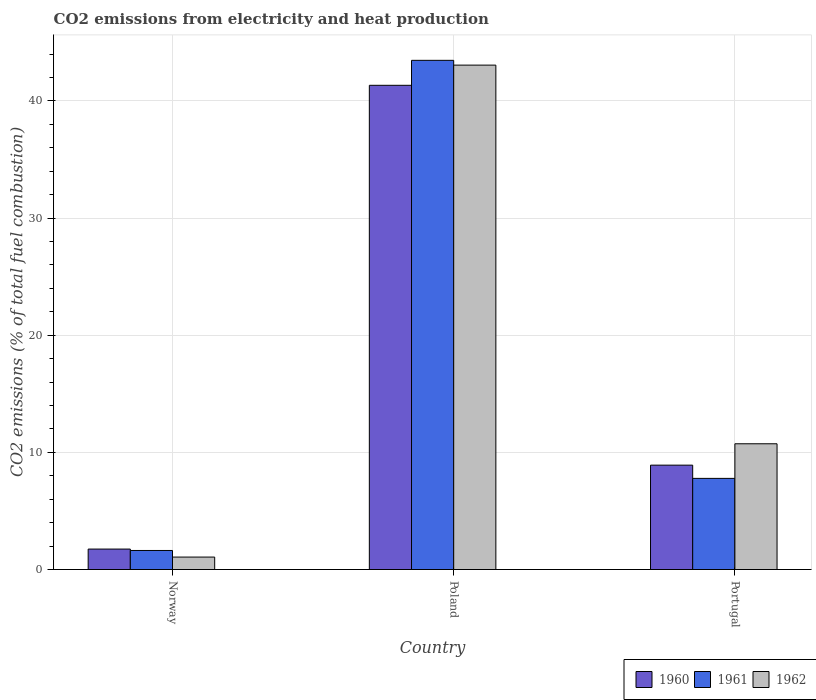How many groups of bars are there?
Your answer should be very brief. 3. How many bars are there on the 3rd tick from the left?
Offer a very short reply. 3. How many bars are there on the 3rd tick from the right?
Ensure brevity in your answer.  3. What is the label of the 3rd group of bars from the left?
Your answer should be compact. Portugal. In how many cases, is the number of bars for a given country not equal to the number of legend labels?
Offer a terse response. 0. What is the amount of CO2 emitted in 1962 in Portugal?
Make the answer very short. 10.73. Across all countries, what is the maximum amount of CO2 emitted in 1962?
Give a very brief answer. 43.06. Across all countries, what is the minimum amount of CO2 emitted in 1962?
Your answer should be very brief. 1.06. What is the total amount of CO2 emitted in 1961 in the graph?
Your answer should be compact. 52.88. What is the difference between the amount of CO2 emitted in 1962 in Norway and that in Portugal?
Give a very brief answer. -9.67. What is the difference between the amount of CO2 emitted in 1961 in Norway and the amount of CO2 emitted in 1962 in Portugal?
Provide a short and direct response. -9.11. What is the average amount of CO2 emitted in 1961 per country?
Your answer should be compact. 17.63. What is the difference between the amount of CO2 emitted of/in 1960 and amount of CO2 emitted of/in 1962 in Portugal?
Provide a succinct answer. -1.82. In how many countries, is the amount of CO2 emitted in 1962 greater than 18 %?
Make the answer very short. 1. What is the ratio of the amount of CO2 emitted in 1961 in Norway to that in Poland?
Keep it short and to the point. 0.04. Is the difference between the amount of CO2 emitted in 1960 in Norway and Portugal greater than the difference between the amount of CO2 emitted in 1962 in Norway and Portugal?
Give a very brief answer. Yes. What is the difference between the highest and the second highest amount of CO2 emitted in 1960?
Offer a very short reply. -32.43. What is the difference between the highest and the lowest amount of CO2 emitted in 1960?
Provide a succinct answer. 39.59. Is it the case that in every country, the sum of the amount of CO2 emitted in 1960 and amount of CO2 emitted in 1962 is greater than the amount of CO2 emitted in 1961?
Offer a terse response. Yes. How many bars are there?
Ensure brevity in your answer.  9. Are all the bars in the graph horizontal?
Your answer should be compact. No. How many countries are there in the graph?
Give a very brief answer. 3. What is the difference between two consecutive major ticks on the Y-axis?
Keep it short and to the point. 10. Are the values on the major ticks of Y-axis written in scientific E-notation?
Keep it short and to the point. No. Does the graph contain grids?
Make the answer very short. Yes. How are the legend labels stacked?
Provide a short and direct response. Horizontal. What is the title of the graph?
Give a very brief answer. CO2 emissions from electricity and heat production. Does "1977" appear as one of the legend labels in the graph?
Your answer should be compact. No. What is the label or title of the X-axis?
Your answer should be very brief. Country. What is the label or title of the Y-axis?
Your answer should be very brief. CO2 emissions (% of total fuel combustion). What is the CO2 emissions (% of total fuel combustion) of 1960 in Norway?
Your response must be concise. 1.75. What is the CO2 emissions (% of total fuel combustion) in 1961 in Norway?
Give a very brief answer. 1.63. What is the CO2 emissions (% of total fuel combustion) of 1962 in Norway?
Offer a very short reply. 1.06. What is the CO2 emissions (% of total fuel combustion) of 1960 in Poland?
Your answer should be very brief. 41.34. What is the CO2 emissions (% of total fuel combustion) in 1961 in Poland?
Your answer should be very brief. 43.47. What is the CO2 emissions (% of total fuel combustion) of 1962 in Poland?
Your response must be concise. 43.06. What is the CO2 emissions (% of total fuel combustion) of 1960 in Portugal?
Ensure brevity in your answer.  8.91. What is the CO2 emissions (% of total fuel combustion) of 1961 in Portugal?
Offer a terse response. 7.78. What is the CO2 emissions (% of total fuel combustion) in 1962 in Portugal?
Offer a very short reply. 10.73. Across all countries, what is the maximum CO2 emissions (% of total fuel combustion) of 1960?
Provide a succinct answer. 41.34. Across all countries, what is the maximum CO2 emissions (% of total fuel combustion) in 1961?
Ensure brevity in your answer.  43.47. Across all countries, what is the maximum CO2 emissions (% of total fuel combustion) of 1962?
Provide a succinct answer. 43.06. Across all countries, what is the minimum CO2 emissions (% of total fuel combustion) of 1960?
Your answer should be compact. 1.75. Across all countries, what is the minimum CO2 emissions (% of total fuel combustion) in 1961?
Offer a terse response. 1.63. Across all countries, what is the minimum CO2 emissions (% of total fuel combustion) of 1962?
Offer a very short reply. 1.06. What is the total CO2 emissions (% of total fuel combustion) in 1960 in the graph?
Offer a very short reply. 51.99. What is the total CO2 emissions (% of total fuel combustion) in 1961 in the graph?
Provide a succinct answer. 52.88. What is the total CO2 emissions (% of total fuel combustion) of 1962 in the graph?
Provide a short and direct response. 54.86. What is the difference between the CO2 emissions (% of total fuel combustion) of 1960 in Norway and that in Poland?
Your response must be concise. -39.59. What is the difference between the CO2 emissions (% of total fuel combustion) in 1961 in Norway and that in Poland?
Keep it short and to the point. -41.84. What is the difference between the CO2 emissions (% of total fuel combustion) of 1962 in Norway and that in Poland?
Provide a succinct answer. -42. What is the difference between the CO2 emissions (% of total fuel combustion) in 1960 in Norway and that in Portugal?
Offer a terse response. -7.16. What is the difference between the CO2 emissions (% of total fuel combustion) of 1961 in Norway and that in Portugal?
Ensure brevity in your answer.  -6.16. What is the difference between the CO2 emissions (% of total fuel combustion) of 1962 in Norway and that in Portugal?
Provide a short and direct response. -9.67. What is the difference between the CO2 emissions (% of total fuel combustion) in 1960 in Poland and that in Portugal?
Make the answer very short. 32.43. What is the difference between the CO2 emissions (% of total fuel combustion) in 1961 in Poland and that in Portugal?
Offer a terse response. 35.69. What is the difference between the CO2 emissions (% of total fuel combustion) of 1962 in Poland and that in Portugal?
Your answer should be very brief. 32.33. What is the difference between the CO2 emissions (% of total fuel combustion) in 1960 in Norway and the CO2 emissions (% of total fuel combustion) in 1961 in Poland?
Offer a terse response. -41.72. What is the difference between the CO2 emissions (% of total fuel combustion) of 1960 in Norway and the CO2 emissions (% of total fuel combustion) of 1962 in Poland?
Offer a terse response. -41.31. What is the difference between the CO2 emissions (% of total fuel combustion) in 1961 in Norway and the CO2 emissions (% of total fuel combustion) in 1962 in Poland?
Provide a succinct answer. -41.44. What is the difference between the CO2 emissions (% of total fuel combustion) of 1960 in Norway and the CO2 emissions (% of total fuel combustion) of 1961 in Portugal?
Give a very brief answer. -6.03. What is the difference between the CO2 emissions (% of total fuel combustion) of 1960 in Norway and the CO2 emissions (% of total fuel combustion) of 1962 in Portugal?
Offer a very short reply. -8.99. What is the difference between the CO2 emissions (% of total fuel combustion) in 1961 in Norway and the CO2 emissions (% of total fuel combustion) in 1962 in Portugal?
Offer a terse response. -9.11. What is the difference between the CO2 emissions (% of total fuel combustion) in 1960 in Poland and the CO2 emissions (% of total fuel combustion) in 1961 in Portugal?
Your response must be concise. 33.56. What is the difference between the CO2 emissions (% of total fuel combustion) of 1960 in Poland and the CO2 emissions (% of total fuel combustion) of 1962 in Portugal?
Your answer should be compact. 30.6. What is the difference between the CO2 emissions (% of total fuel combustion) in 1961 in Poland and the CO2 emissions (% of total fuel combustion) in 1962 in Portugal?
Your answer should be very brief. 32.73. What is the average CO2 emissions (% of total fuel combustion) in 1960 per country?
Offer a very short reply. 17.33. What is the average CO2 emissions (% of total fuel combustion) of 1961 per country?
Offer a very short reply. 17.63. What is the average CO2 emissions (% of total fuel combustion) in 1962 per country?
Ensure brevity in your answer.  18.29. What is the difference between the CO2 emissions (% of total fuel combustion) of 1960 and CO2 emissions (% of total fuel combustion) of 1961 in Norway?
Ensure brevity in your answer.  0.12. What is the difference between the CO2 emissions (% of total fuel combustion) of 1960 and CO2 emissions (% of total fuel combustion) of 1962 in Norway?
Make the answer very short. 0.68. What is the difference between the CO2 emissions (% of total fuel combustion) of 1961 and CO2 emissions (% of total fuel combustion) of 1962 in Norway?
Your response must be concise. 0.56. What is the difference between the CO2 emissions (% of total fuel combustion) in 1960 and CO2 emissions (% of total fuel combustion) in 1961 in Poland?
Ensure brevity in your answer.  -2.13. What is the difference between the CO2 emissions (% of total fuel combustion) in 1960 and CO2 emissions (% of total fuel combustion) in 1962 in Poland?
Offer a very short reply. -1.72. What is the difference between the CO2 emissions (% of total fuel combustion) of 1961 and CO2 emissions (% of total fuel combustion) of 1962 in Poland?
Give a very brief answer. 0.41. What is the difference between the CO2 emissions (% of total fuel combustion) of 1960 and CO2 emissions (% of total fuel combustion) of 1961 in Portugal?
Ensure brevity in your answer.  1.13. What is the difference between the CO2 emissions (% of total fuel combustion) in 1960 and CO2 emissions (% of total fuel combustion) in 1962 in Portugal?
Provide a short and direct response. -1.82. What is the difference between the CO2 emissions (% of total fuel combustion) in 1961 and CO2 emissions (% of total fuel combustion) in 1962 in Portugal?
Ensure brevity in your answer.  -2.95. What is the ratio of the CO2 emissions (% of total fuel combustion) of 1960 in Norway to that in Poland?
Keep it short and to the point. 0.04. What is the ratio of the CO2 emissions (% of total fuel combustion) in 1961 in Norway to that in Poland?
Offer a terse response. 0.04. What is the ratio of the CO2 emissions (% of total fuel combustion) in 1962 in Norway to that in Poland?
Offer a terse response. 0.02. What is the ratio of the CO2 emissions (% of total fuel combustion) of 1960 in Norway to that in Portugal?
Keep it short and to the point. 0.2. What is the ratio of the CO2 emissions (% of total fuel combustion) in 1961 in Norway to that in Portugal?
Give a very brief answer. 0.21. What is the ratio of the CO2 emissions (% of total fuel combustion) of 1962 in Norway to that in Portugal?
Offer a very short reply. 0.1. What is the ratio of the CO2 emissions (% of total fuel combustion) of 1960 in Poland to that in Portugal?
Provide a succinct answer. 4.64. What is the ratio of the CO2 emissions (% of total fuel combustion) in 1961 in Poland to that in Portugal?
Your answer should be compact. 5.59. What is the ratio of the CO2 emissions (% of total fuel combustion) of 1962 in Poland to that in Portugal?
Keep it short and to the point. 4.01. What is the difference between the highest and the second highest CO2 emissions (% of total fuel combustion) in 1960?
Offer a terse response. 32.43. What is the difference between the highest and the second highest CO2 emissions (% of total fuel combustion) in 1961?
Your response must be concise. 35.69. What is the difference between the highest and the second highest CO2 emissions (% of total fuel combustion) in 1962?
Offer a very short reply. 32.33. What is the difference between the highest and the lowest CO2 emissions (% of total fuel combustion) in 1960?
Offer a very short reply. 39.59. What is the difference between the highest and the lowest CO2 emissions (% of total fuel combustion) in 1961?
Ensure brevity in your answer.  41.84. What is the difference between the highest and the lowest CO2 emissions (% of total fuel combustion) in 1962?
Offer a very short reply. 42. 